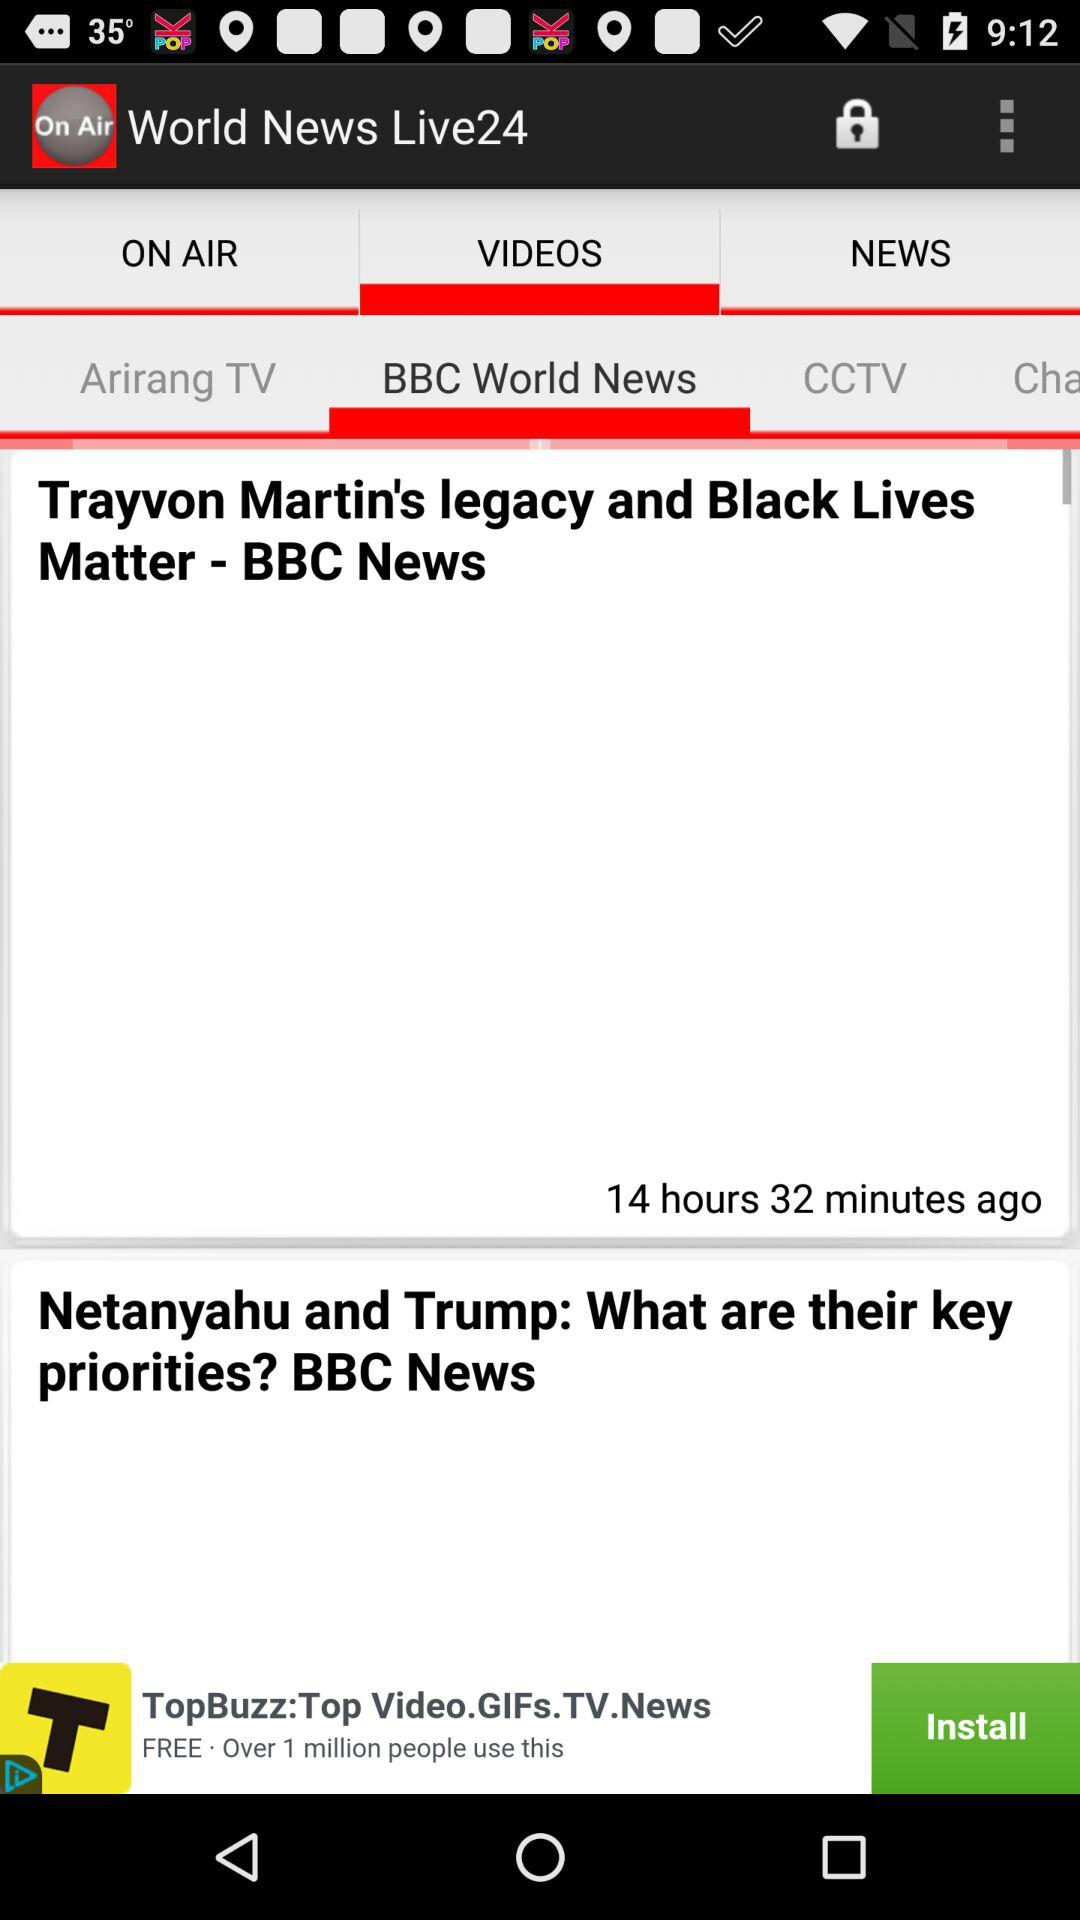Which tab is selected? The selected tabs are "VIDEOS" and "BBC World News". 